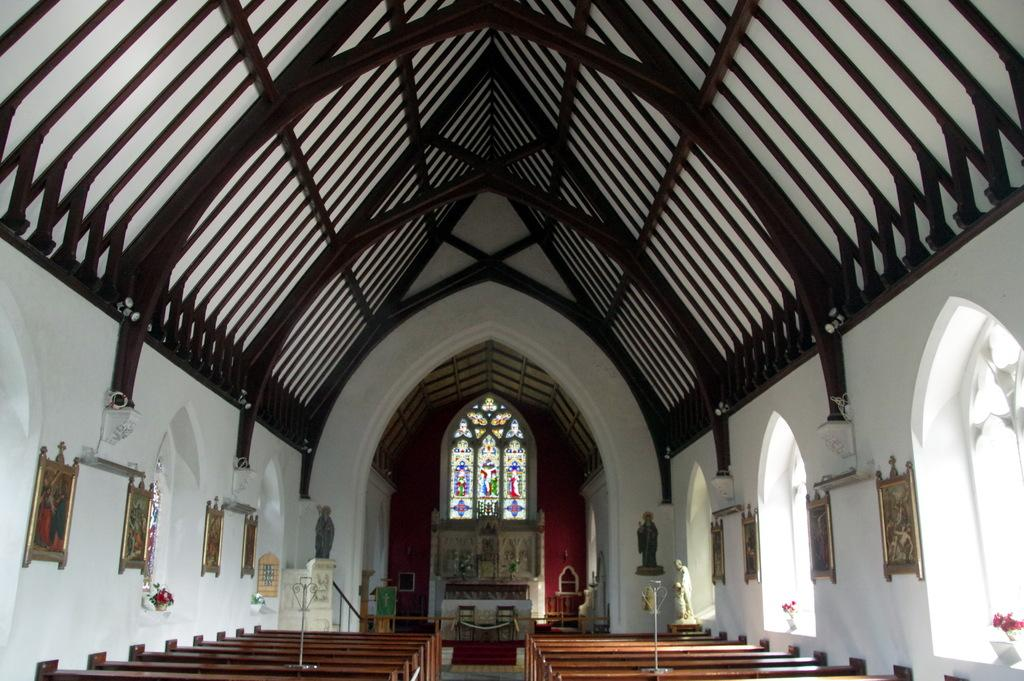What is the setting of the image? The image shows the inside of a building. What can be seen on the walls of the building? There are frames on the walls. What type of material is used to support the roof of the building? There are wooden pillars supporting the roof. What type of note is being passed between the two people in the image? There are no people present in the image, and therefore no note-passing activity can be observed. 